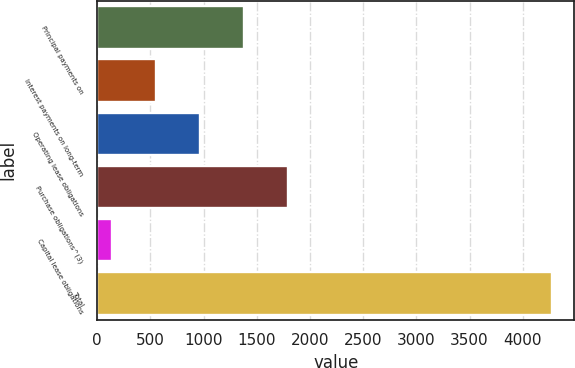Convert chart. <chart><loc_0><loc_0><loc_500><loc_500><bar_chart><fcel>Principal payments on<fcel>Interest payments on long-term<fcel>Operating lease obligations<fcel>Purchase obligations^(3)<fcel>Capital lease obligations<fcel>Total<nl><fcel>1375.1<fcel>547.7<fcel>961.4<fcel>1788.8<fcel>134<fcel>4271<nl></chart> 